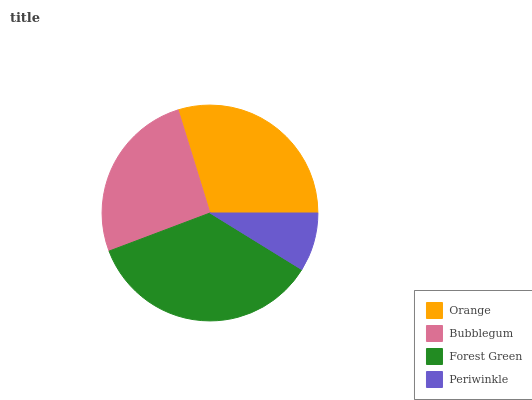Is Periwinkle the minimum?
Answer yes or no. Yes. Is Forest Green the maximum?
Answer yes or no. Yes. Is Bubblegum the minimum?
Answer yes or no. No. Is Bubblegum the maximum?
Answer yes or no. No. Is Orange greater than Bubblegum?
Answer yes or no. Yes. Is Bubblegum less than Orange?
Answer yes or no. Yes. Is Bubblegum greater than Orange?
Answer yes or no. No. Is Orange less than Bubblegum?
Answer yes or no. No. Is Orange the high median?
Answer yes or no. Yes. Is Bubblegum the low median?
Answer yes or no. Yes. Is Bubblegum the high median?
Answer yes or no. No. Is Orange the low median?
Answer yes or no. No. 